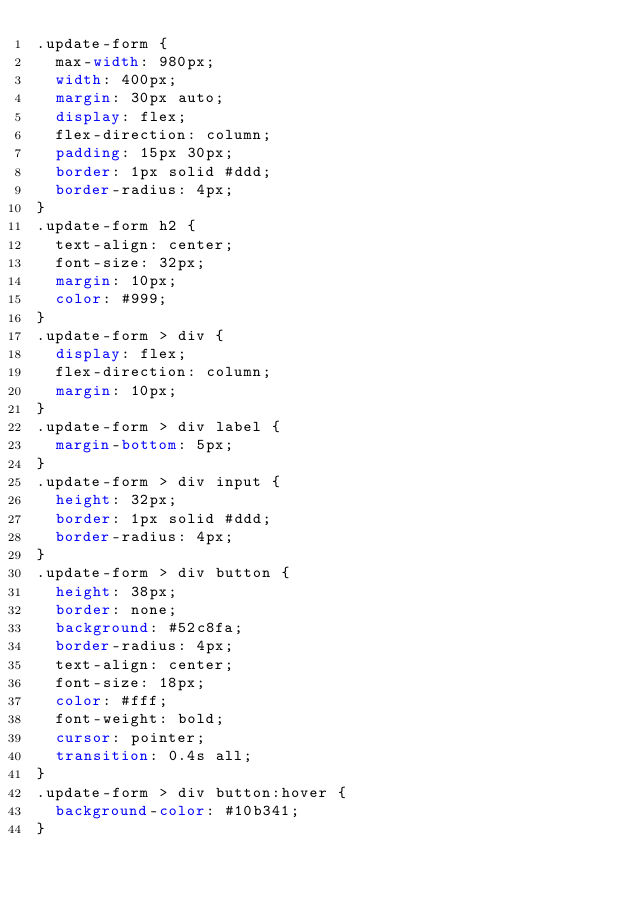Convert code to text. <code><loc_0><loc_0><loc_500><loc_500><_CSS_>.update-form {
  max-width: 980px;
  width: 400px;
  margin: 30px auto;
  display: flex;
  flex-direction: column;
  padding: 15px 30px;
  border: 1px solid #ddd;
  border-radius: 4px;
}
.update-form h2 {
  text-align: center;
  font-size: 32px;
  margin: 10px;
  color: #999;
}
.update-form > div {
  display: flex;
  flex-direction: column;
  margin: 10px;
}
.update-form > div label {
  margin-bottom: 5px;
}
.update-form > div input {
  height: 32px;
  border: 1px solid #ddd;
  border-radius: 4px;
}
.update-form > div button {
  height: 38px;
  border: none;
  background: #52c8fa;
  border-radius: 4px;
  text-align: center;
  font-size: 18px;
  color: #fff;
  font-weight: bold;
  cursor: pointer;
  transition: 0.4s all;
}
.update-form > div button:hover {
  background-color: #10b341;
}
</code> 